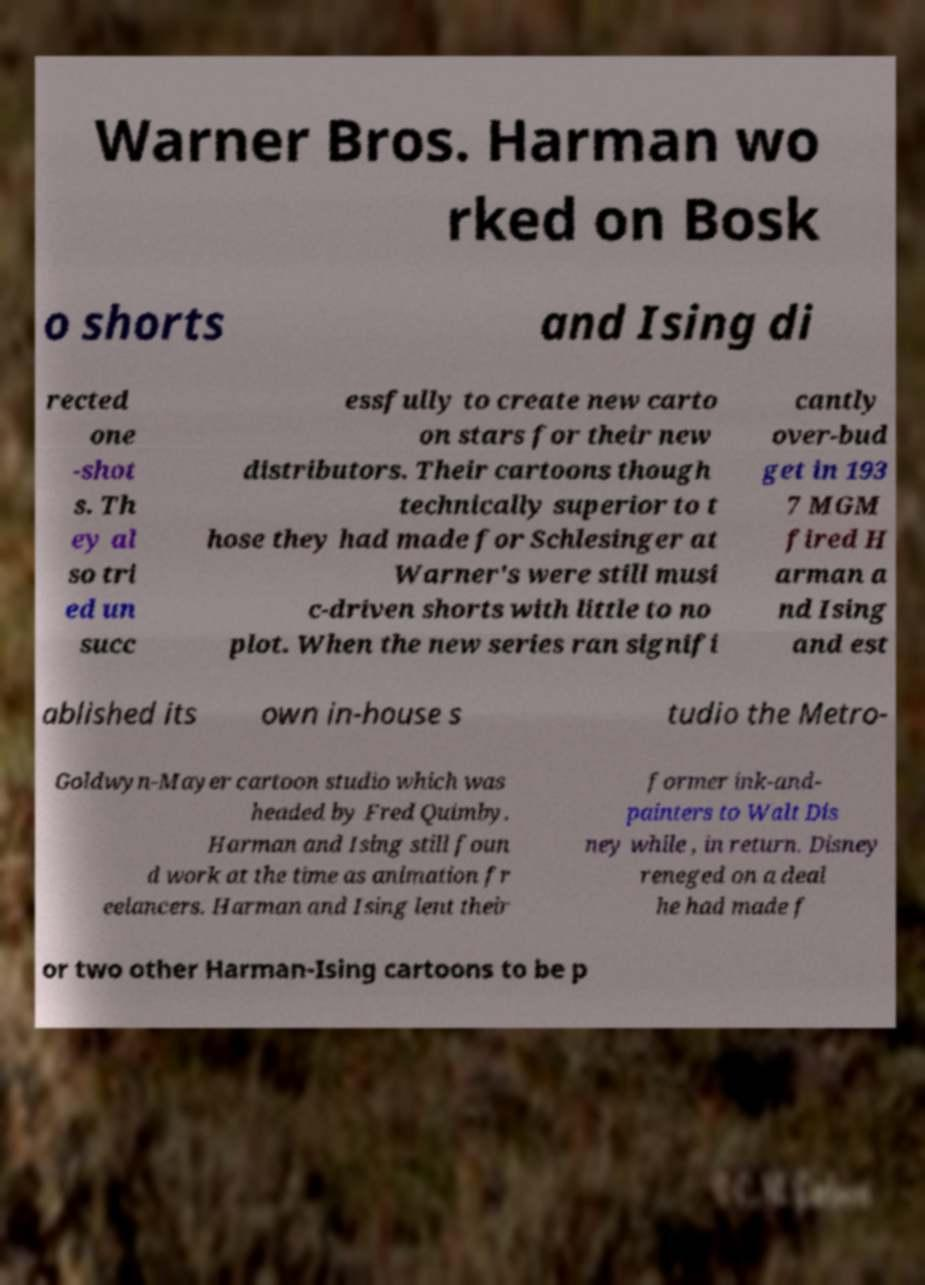There's text embedded in this image that I need extracted. Can you transcribe it verbatim? Warner Bros. Harman wo rked on Bosk o shorts and Ising di rected one -shot s. Th ey al so tri ed un succ essfully to create new carto on stars for their new distributors. Their cartoons though technically superior to t hose they had made for Schlesinger at Warner's were still musi c-driven shorts with little to no plot. When the new series ran signifi cantly over-bud get in 193 7 MGM fired H arman a nd Ising and est ablished its own in-house s tudio the Metro- Goldwyn-Mayer cartoon studio which was headed by Fred Quimby. Harman and Ising still foun d work at the time as animation fr eelancers. Harman and Ising lent their former ink-and- painters to Walt Dis ney while , in return. Disney reneged on a deal he had made f or two other Harman-Ising cartoons to be p 